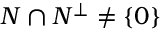Convert formula to latex. <formula><loc_0><loc_0><loc_500><loc_500>N \cap N ^ { \bot } \neq \{ 0 \}</formula> 